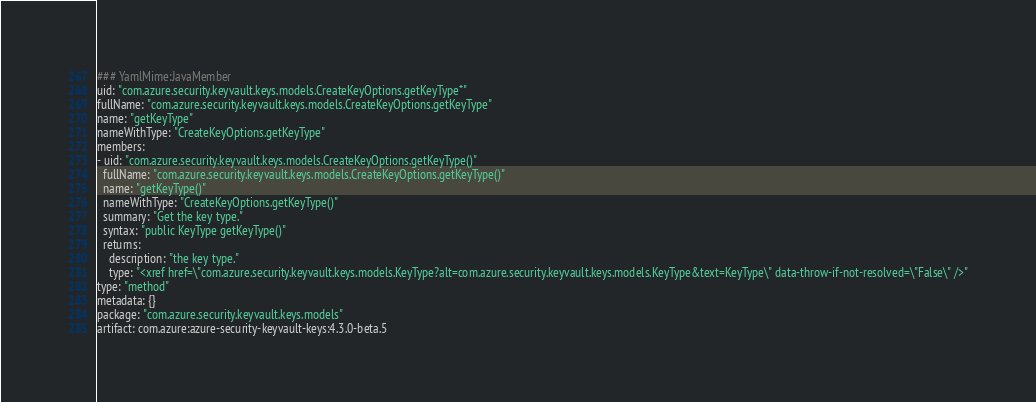<code> <loc_0><loc_0><loc_500><loc_500><_YAML_>### YamlMime:JavaMember
uid: "com.azure.security.keyvault.keys.models.CreateKeyOptions.getKeyType*"
fullName: "com.azure.security.keyvault.keys.models.CreateKeyOptions.getKeyType"
name: "getKeyType"
nameWithType: "CreateKeyOptions.getKeyType"
members:
- uid: "com.azure.security.keyvault.keys.models.CreateKeyOptions.getKeyType()"
  fullName: "com.azure.security.keyvault.keys.models.CreateKeyOptions.getKeyType()"
  name: "getKeyType()"
  nameWithType: "CreateKeyOptions.getKeyType()"
  summary: "Get the key type."
  syntax: "public KeyType getKeyType()"
  returns:
    description: "the key type."
    type: "<xref href=\"com.azure.security.keyvault.keys.models.KeyType?alt=com.azure.security.keyvault.keys.models.KeyType&text=KeyType\" data-throw-if-not-resolved=\"False\" />"
type: "method"
metadata: {}
package: "com.azure.security.keyvault.keys.models"
artifact: com.azure:azure-security-keyvault-keys:4.3.0-beta.5
</code> 